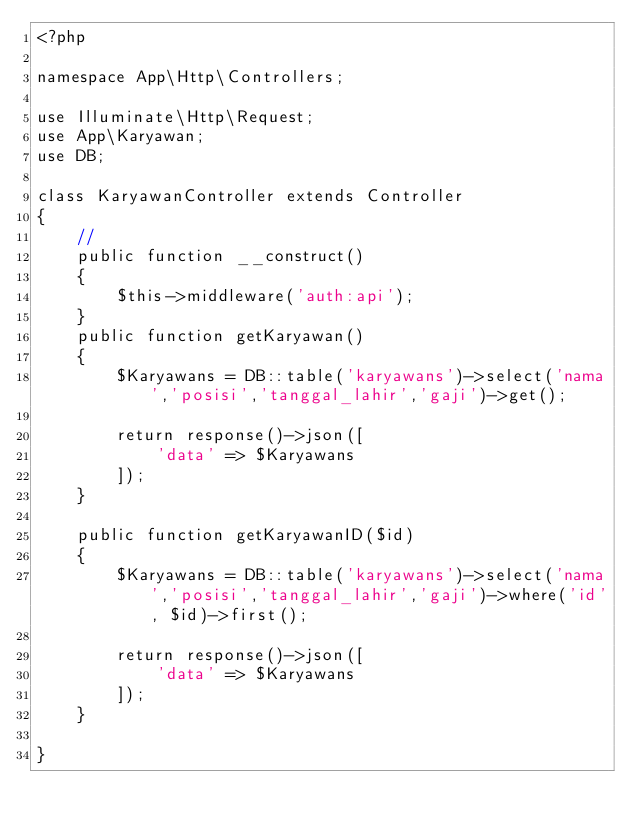<code> <loc_0><loc_0><loc_500><loc_500><_PHP_><?php

namespace App\Http\Controllers;

use Illuminate\Http\Request;
use App\Karyawan;
use DB;

class KaryawanController extends Controller
{
    //
    public function __construct()
    {
        $this->middleware('auth:api');
    }
    public function getKaryawan()
    {
        $Karyawans = DB::table('karyawans')->select('nama','posisi','tanggal_lahir','gaji')->get();

        return response()->json([
            'data' => $Karyawans
        ]);
    }

    public function getKaryawanID($id) 
    {
        $Karyawans = DB::table('karyawans')->select('nama','posisi','tanggal_lahir','gaji')->where('id', $id)->first();

        return response()->json([
            'data' => $Karyawans
        ]);
    }

}
</code> 